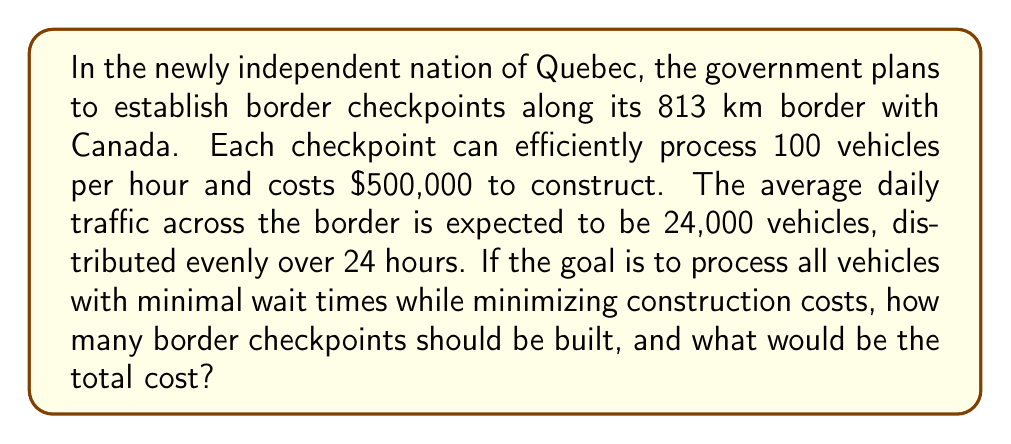Can you answer this question? Let's approach this step-by-step:

1) First, we need to calculate the hourly traffic flow:
   $$ \text{Hourly traffic} = \frac{24,000 \text{ vehicles}}{24 \text{ hours}} = 1,000 \text{ vehicles per hour} $$

2) Now, we need to determine how many checkpoints are needed to handle this traffic:
   $$ \text{Number of checkpoints} = \frac{\text{Hourly traffic}}{\text{Vehicles processed per checkpoint per hour}} $$
   $$ = \frac{1,000}{100} = 10 \text{ checkpoints} $$

3) To calculate the total cost, we multiply the number of checkpoints by the cost per checkpoint:
   $$ \text{Total cost} = 10 \times \$500,000 = \$5,000,000 $$

4) We should also consider the distribution of these checkpoints. With 813 km of border and 10 checkpoints, they would ideally be spaced evenly:
   $$ \text{Distance between checkpoints} = \frac{813 \text{ km}}{10} = 81.3 \text{ km} $$

This solution ensures that all vehicles can be processed efficiently without excessive wait times, while also minimizing the construction costs.
Answer: Quebec should construct 10 border checkpoints at a total cost of $5,000,000. These checkpoints should be evenly distributed approximately 81.3 km apart along the 813 km border with Canada. 